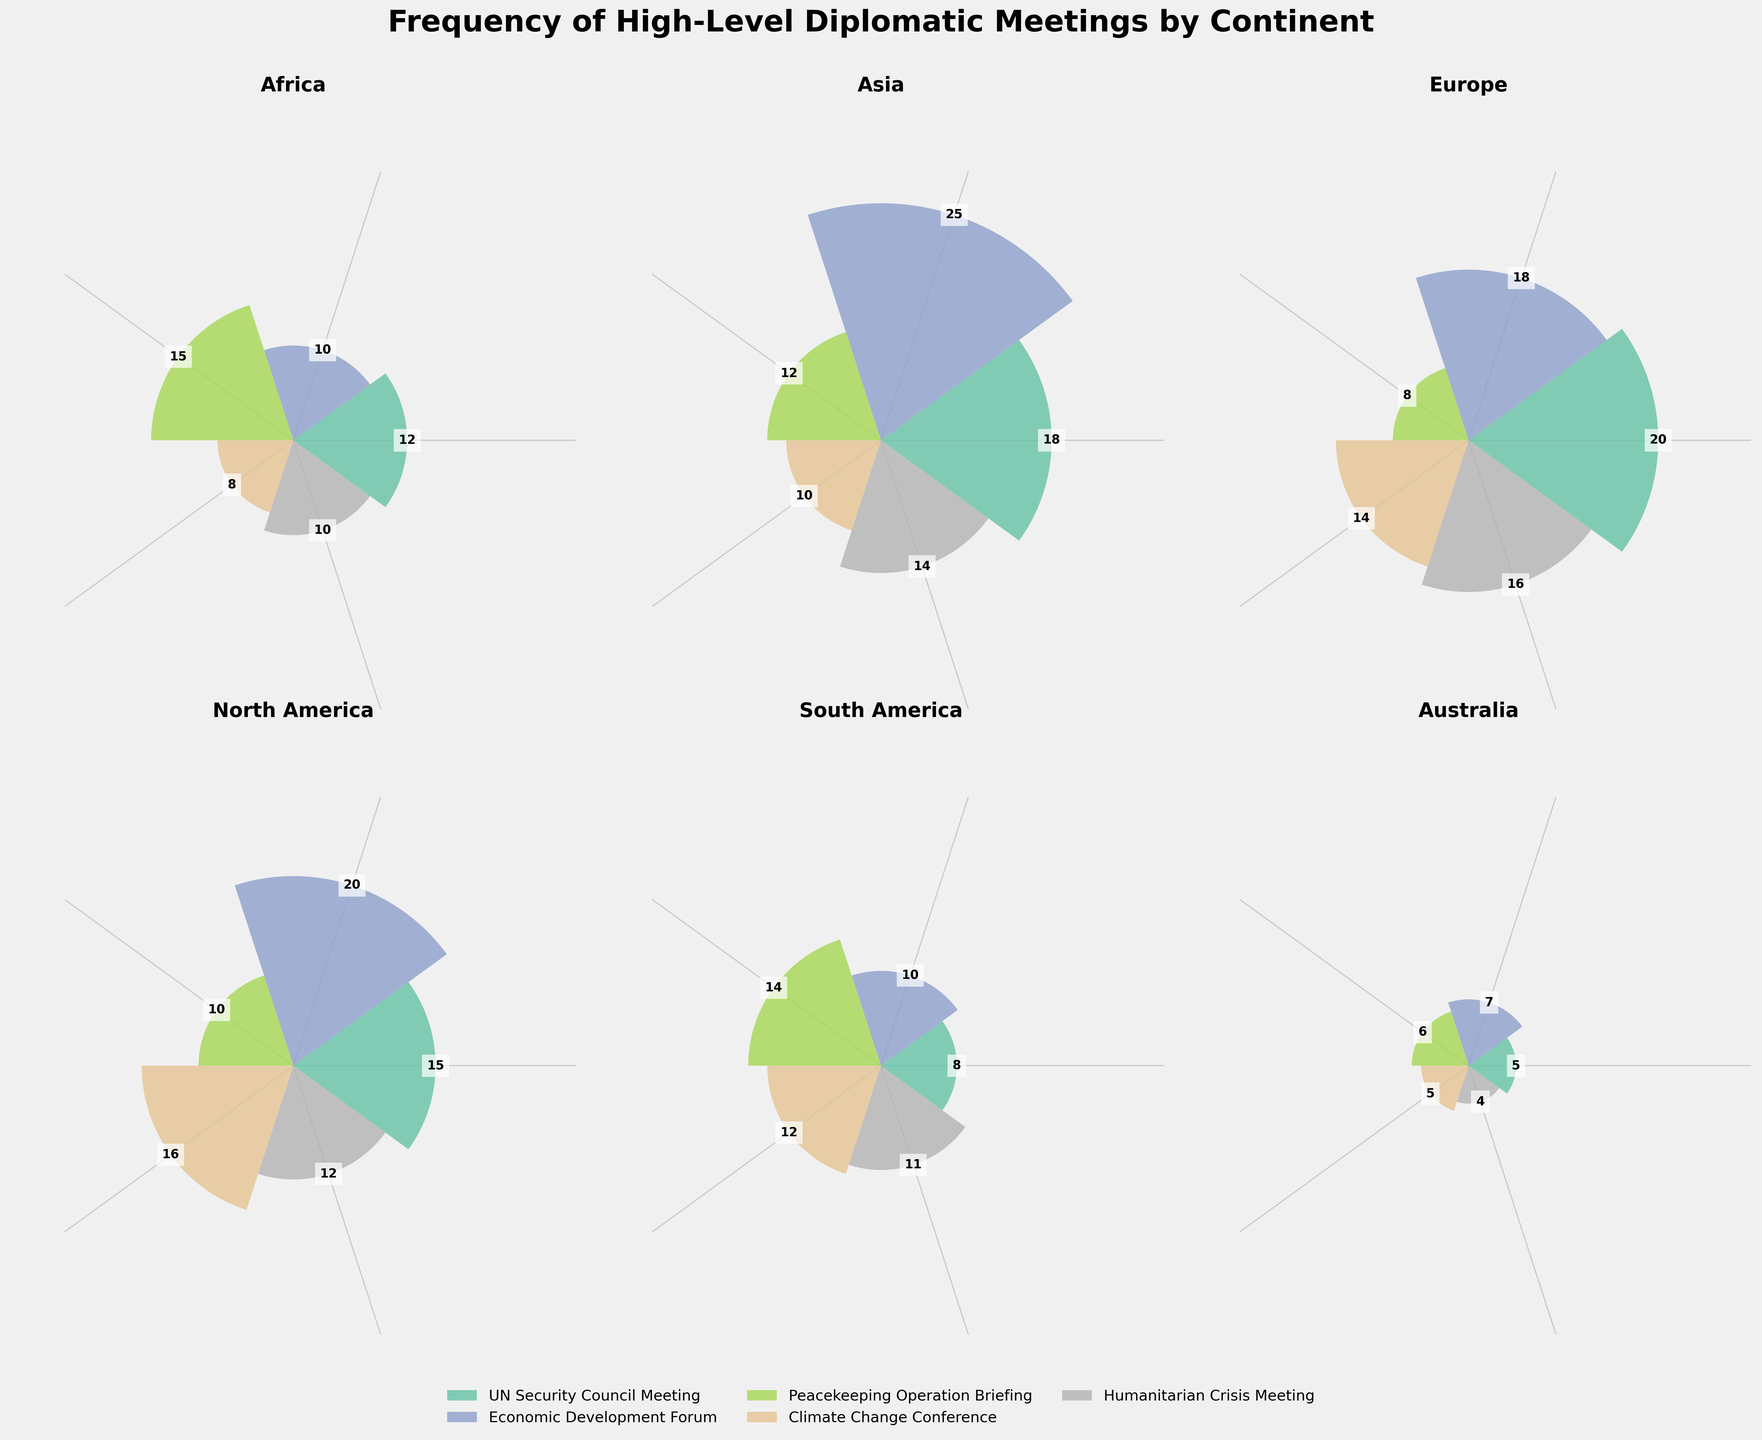What's the continent with the highest frequency of UN Security Council Meetings? The bar representing UN Security Council Meetings is highest in the subplot titled "Europe".
Answer: Europe Which continent has the lowest frequency of Humanitarian Crisis Meetings? The height of the bar for Humanitarian Crisis Meetings is lowest in the subplot titled "Australia".
Answer: Australia What is the total frequency of Peacekeeping Operation Briefings for Africa and Asia combined? Adding the frequency of Peacekeeping Operation Briefings in Africa (15) and Asia (12) yields 15 + 12 = 27.
Answer: 27 Compare the frequencies of Economic Development Forums in Europe and North America. Which is higher? The bar for Economic Development Forum is higher in the subplot titled "North America" (20) compared to "Europe" (18).
Answer: North America Does any continent have an equal frequency for Climate Change Conferences and Humanitarian Crisis Meetings? In South America, the frequency for Climate Change Conferences (12) is equal to the frequency for Humanitarian Crisis Meetings (11).
Answer: No What's the average frequency of all types of meetings in North America? The sum of all frequencies in North America is 15 (UN Security Council Meeting) + 20 (Economic Development Forum) + 10 (Peacekeeping Operation Briefing) + 16 (Climate Change Conference) + 12 (Humanitarian Crisis Meeting) = 73. There are 5 types of meetings, so the average is 73 / 5 = 14.6.
Answer: 14.6 Which type of meeting has the widest range of frequencies across all continents? The highest frequency for Economic Development Forum is 25 (Asia) and the lowest is 7 (Australia). The range is 25 - 7 = 18, which is higher than the range for other meeting types.
Answer: Economic Development Forum How does the frequency of Climate Change Conferences in Africa compare to that in South America? The frequency in Africa is 8, while in South America, it is 12. Therefore, Africa has fewer Climate Change Conferences compared to South America.
Answer: South America Identify the continent with the highest number of total high-level diplomatic meetings. Adding frequencies for all meeting types in each continent, Asia has the highest total with 18 + 25 + 12 + 10 + 14 = 79.
Answer: Asia 